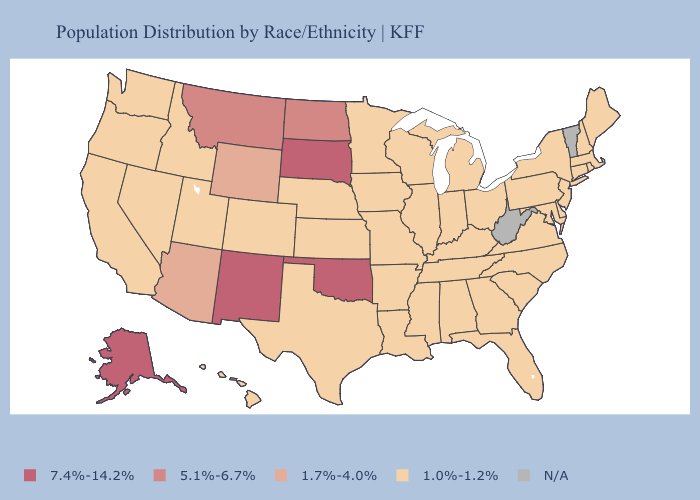Does the first symbol in the legend represent the smallest category?
Answer briefly. No. Name the states that have a value in the range N/A?
Give a very brief answer. Vermont, West Virginia. Does Indiana have the lowest value in the USA?
Be succinct. Yes. Which states have the lowest value in the South?
Answer briefly. Alabama, Arkansas, Delaware, Florida, Georgia, Kentucky, Louisiana, Maryland, Mississippi, North Carolina, South Carolina, Tennessee, Texas, Virginia. Which states have the highest value in the USA?
Concise answer only. Alaska, New Mexico, Oklahoma, South Dakota. What is the highest value in the USA?
Concise answer only. 7.4%-14.2%. Does Minnesota have the highest value in the MidWest?
Be succinct. No. What is the highest value in the USA?
Write a very short answer. 7.4%-14.2%. Which states hav the highest value in the South?
Short answer required. Oklahoma. What is the highest value in the MidWest ?
Quick response, please. 7.4%-14.2%. Which states have the lowest value in the Northeast?
Short answer required. Connecticut, Maine, Massachusetts, New Hampshire, New Jersey, New York, Pennsylvania, Rhode Island. 